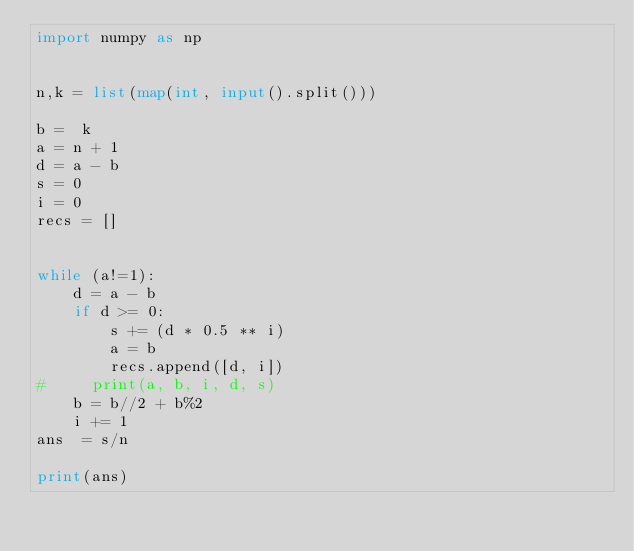<code> <loc_0><loc_0><loc_500><loc_500><_Python_>import numpy as np


n,k = list(map(int, input().split()))

b =  k
a = n + 1
d = a - b
s = 0
i = 0
recs = []


while (a!=1):
    d = a - b
    if d >= 0:
        s += (d * 0.5 ** i)
        a = b
        recs.append([d, i])
#     print(a, b, i, d, s)
    b = b//2 + b%2
    i += 1
ans  = s/n

print(ans)</code> 